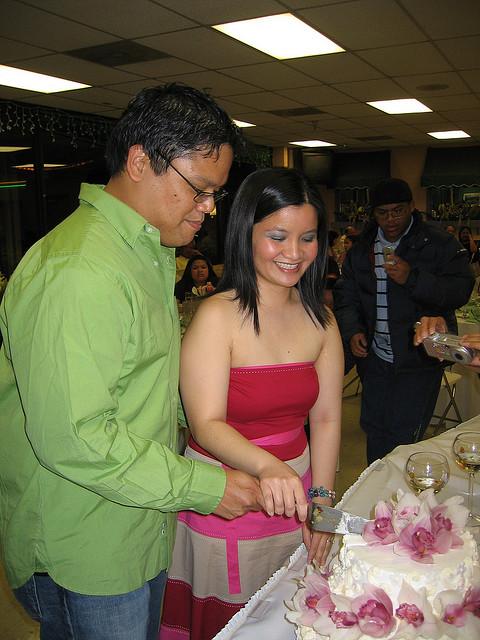What type of cake is this?
Concise answer only. Wedding. What are the people doing?
Keep it brief. Cutting cake. Where are the wine glasses?
Concise answer only. Table. 